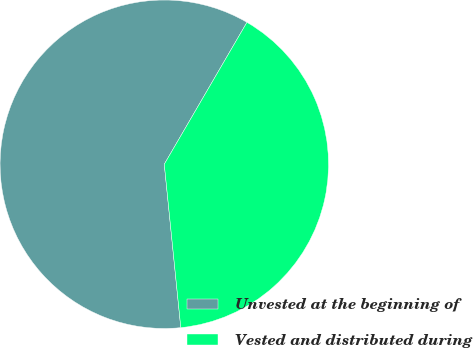Convert chart to OTSL. <chart><loc_0><loc_0><loc_500><loc_500><pie_chart><fcel>Unvested at the beginning of<fcel>Vested and distributed during<nl><fcel>60.0%<fcel>40.0%<nl></chart> 